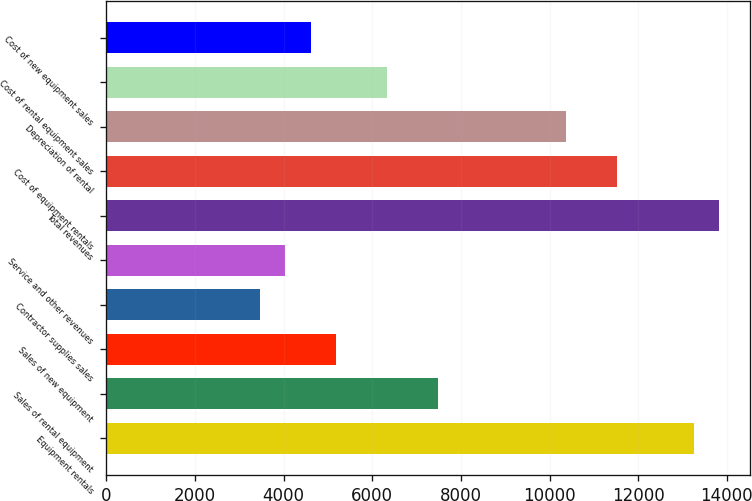Convert chart. <chart><loc_0><loc_0><loc_500><loc_500><bar_chart><fcel>Equipment rentals<fcel>Sales of rental equipment<fcel>Sales of new equipment<fcel>Contractor supplies sales<fcel>Service and other revenues<fcel>Total revenues<fcel>Cost of equipment rentals<fcel>Depreciation of rental<fcel>Cost of rental equipment sales<fcel>Cost of new equipment sales<nl><fcel>13246.1<fcel>7489.1<fcel>5186.3<fcel>3459.2<fcel>4034.9<fcel>13821.8<fcel>11519<fcel>10367.6<fcel>6337.7<fcel>4610.6<nl></chart> 